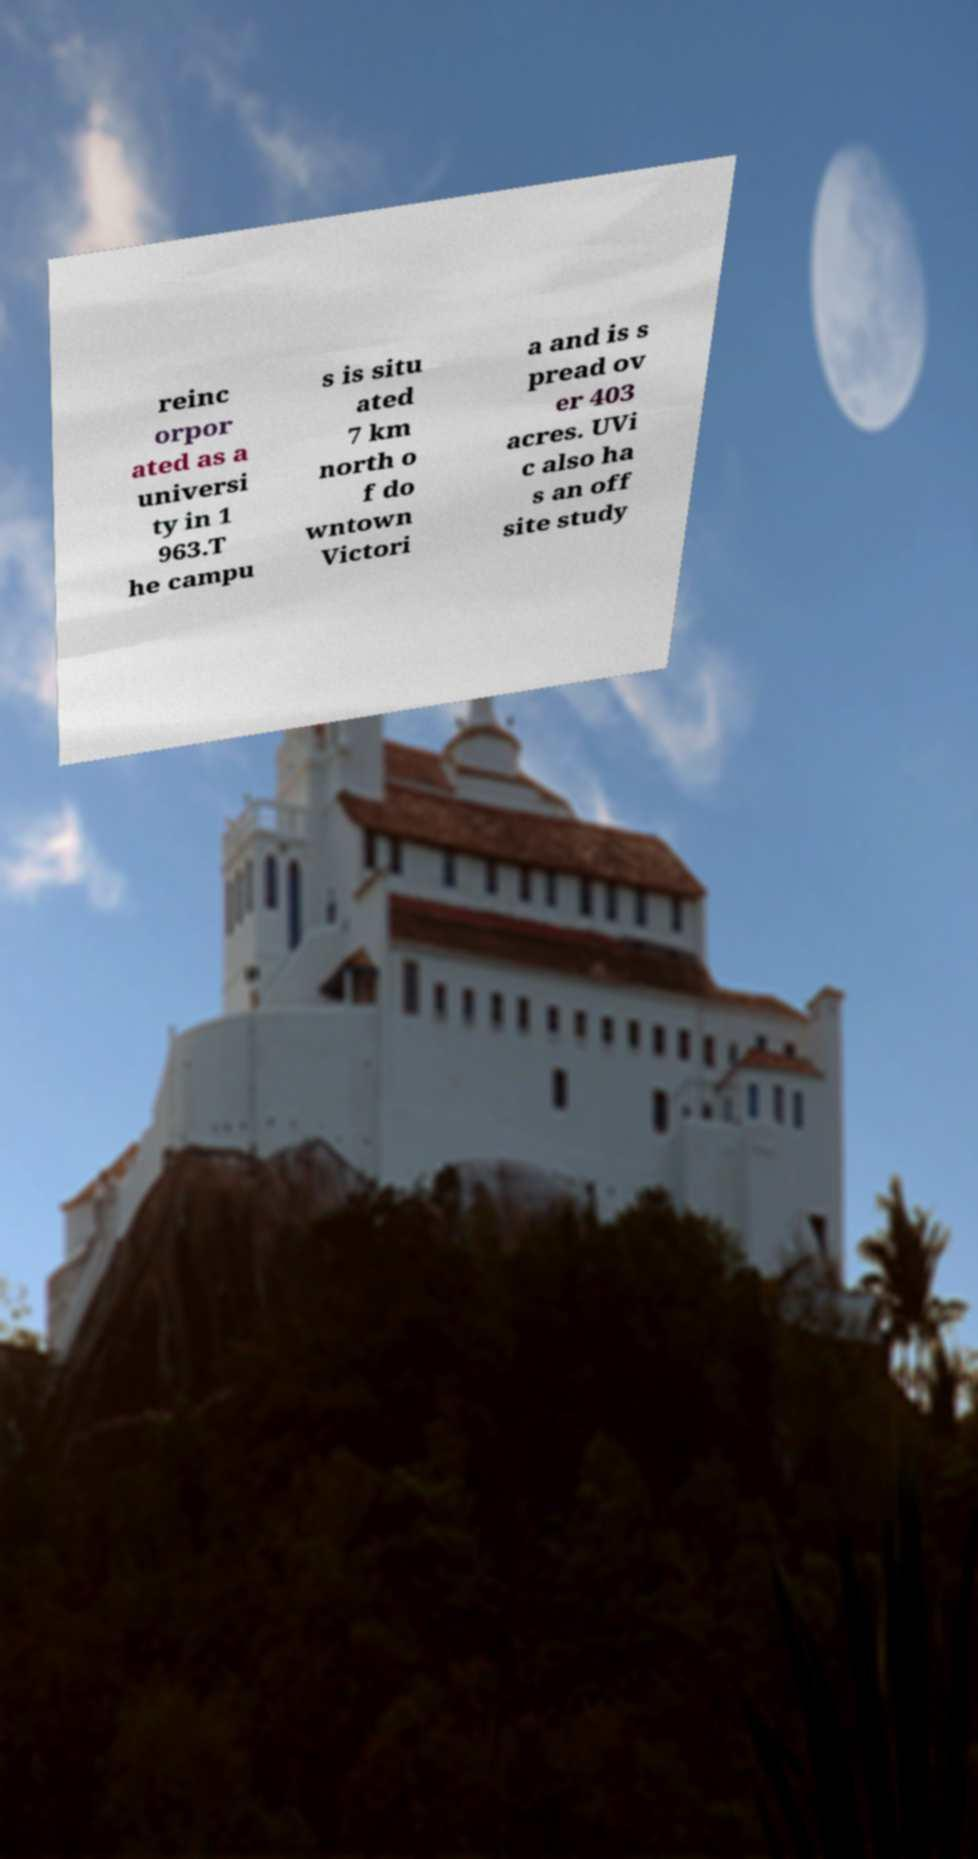Can you accurately transcribe the text from the provided image for me? reinc orpor ated as a universi ty in 1 963.T he campu s is situ ated 7 km north o f do wntown Victori a and is s pread ov er 403 acres. UVi c also ha s an off site study 